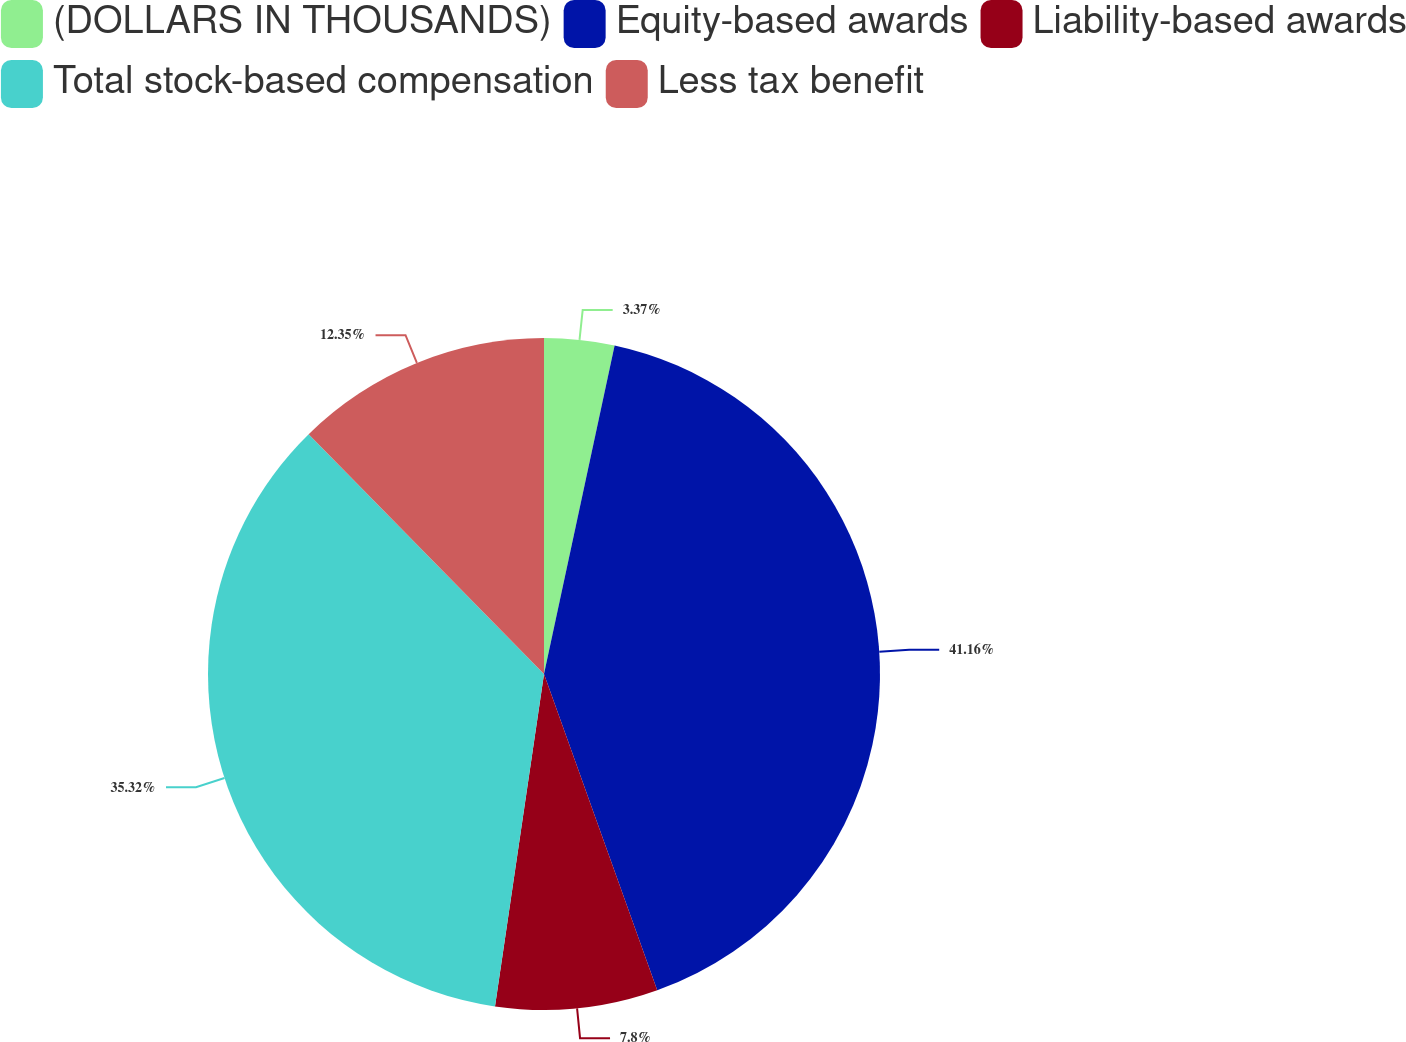Convert chart to OTSL. <chart><loc_0><loc_0><loc_500><loc_500><pie_chart><fcel>(DOLLARS IN THOUSANDS)<fcel>Equity-based awards<fcel>Liability-based awards<fcel>Total stock-based compensation<fcel>Less tax benefit<nl><fcel>3.37%<fcel>41.16%<fcel>7.8%<fcel>35.32%<fcel>12.35%<nl></chart> 